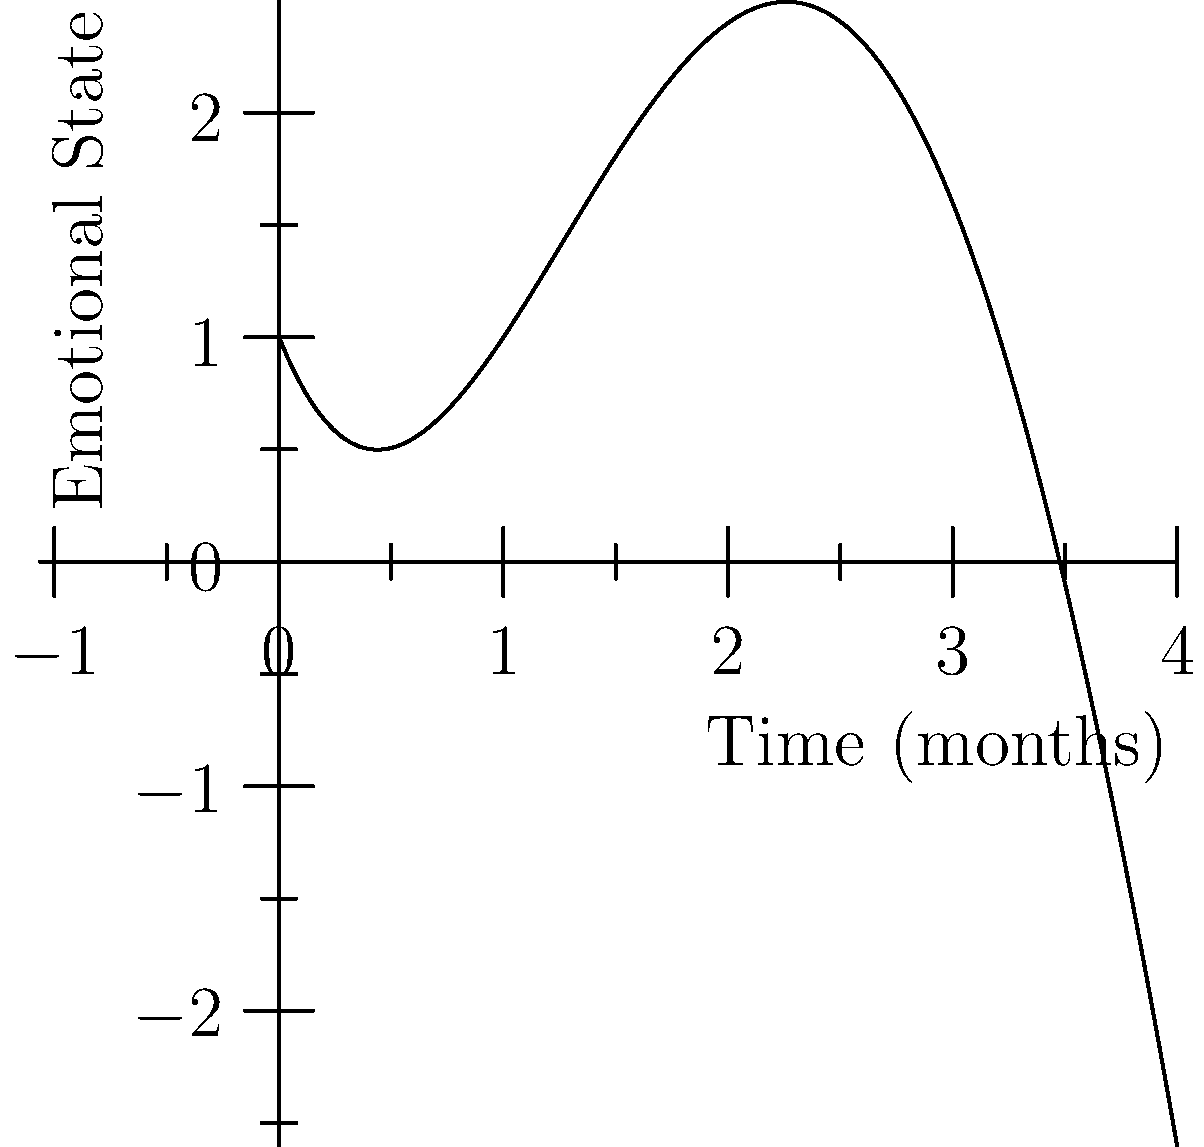The quartic polynomial $f(x) = 0.1x^4 - 1.2x^3 + 3.6x^2 - 2.5x + 1$ represents the emotional state of a trauma survivor over time, where $x$ is the number of months since starting therapy and $f(x)$ represents their emotional well-being. At what point(s) does the survivor experience a local minimum in their emotional state? To find the local minima, we need to follow these steps:

1) First, find the derivative of the function:
   $f'(x) = 0.4x^3 - 3.6x^2 + 7.2x - 2.5$

2) Set the derivative equal to zero and solve for x:
   $0.4x^3 - 3.6x^2 + 7.2x - 2.5 = 0$

3) This cubic equation is difficult to solve by hand, but we can use a graphing calculator or computer algebra system to find the roots. The roots are approximately:

   $x ≈ 0.4$ and $x ≈ 2.8$

4) To determine which of these is a local minimum, we need to check the second derivative:
   $f''(x) = 1.2x^2 - 7.2x + 7.2$

5) Evaluate $f''(x)$ at each critical point:
   $f''(0.4) ≈ 4.8$ (positive, local minimum)
   $f''(2.8) ≈ -0.48$ (negative, local maximum)

Therefore, the local minimum occurs at approximately $x = 0.4$ months.
Answer: 0.4 months 